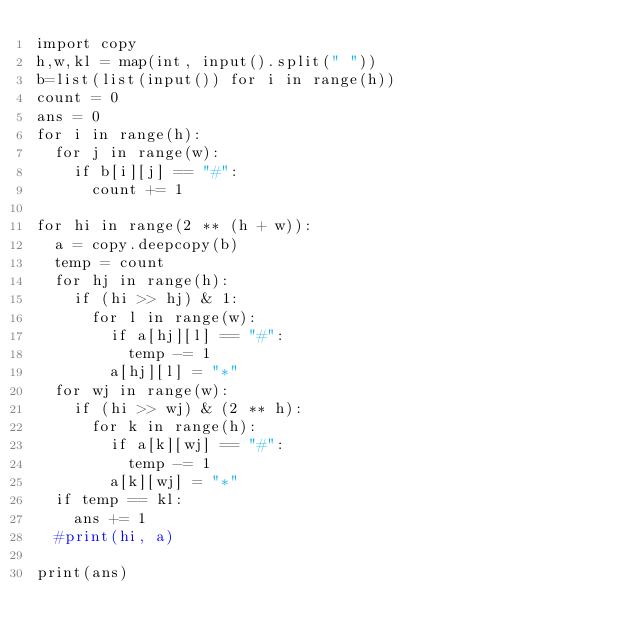Convert code to text. <code><loc_0><loc_0><loc_500><loc_500><_Python_>import copy
h,w,kl = map(int, input().split(" "))
b=list(list(input()) for i in range(h))
count = 0
ans = 0
for i in range(h):
  for j in range(w):
    if b[i][j] == "#":
      count += 1
      
for hi in range(2 ** (h + w)):
  a = copy.deepcopy(b)
  temp = count
  for hj in range(h):
    if (hi >> hj) & 1:
      for l in range(w):
        if a[hj][l] == "#":
          temp -= 1
        a[hj][l] = "*"
  for wj in range(w):
    if (hi >> wj) & (2 ** h):
      for k in range(h):
        if a[k][wj] == "#":
          temp -= 1
        a[k][wj] = "*"
  if temp == kl:
    ans += 1 
  #print(hi, a)
  
print(ans)</code> 